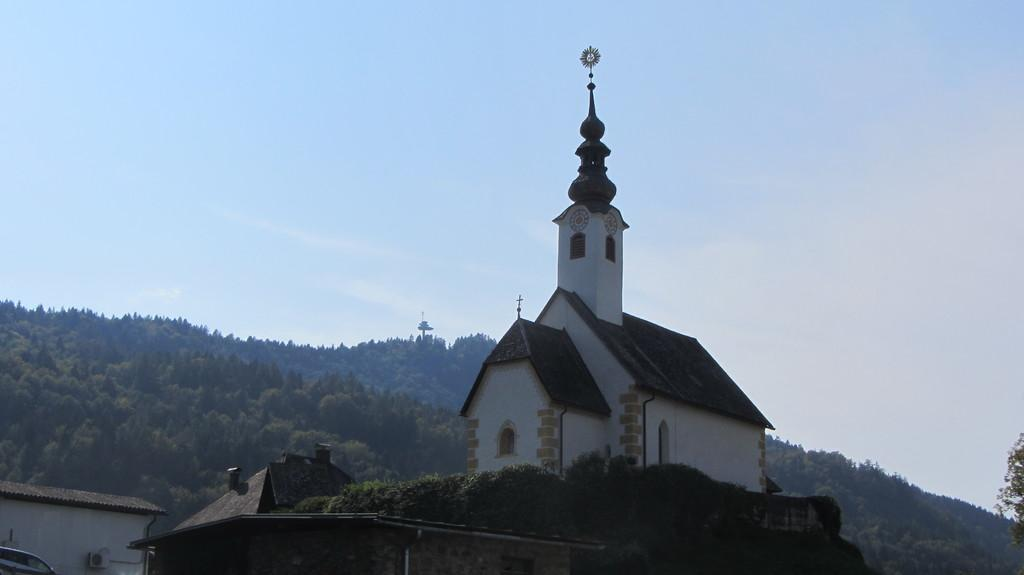What type of structure is in the image? There is a building in the image. What colors are used on the building? The building has white and brown colors. What can be seen in the background of the image? There are trees and the sky visible in the background of the image. What color are the trees? The trees have green colors. What color is the sky in the image? The sky has a blue color. What type of wrench is being used to fix the building in the image? There is no wrench present in the image, and the building does not appear to be undergoing any repairs. 